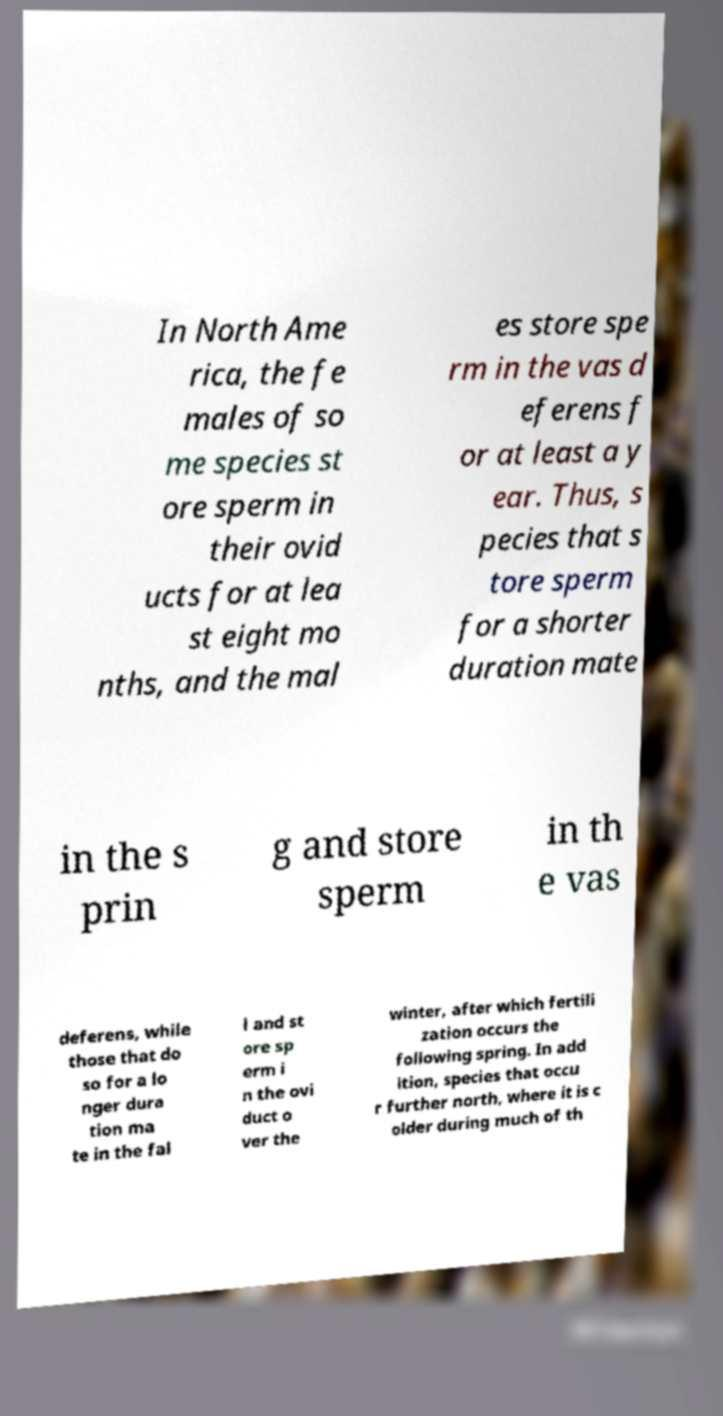Can you accurately transcribe the text from the provided image for me? In North Ame rica, the fe males of so me species st ore sperm in their ovid ucts for at lea st eight mo nths, and the mal es store spe rm in the vas d eferens f or at least a y ear. Thus, s pecies that s tore sperm for a shorter duration mate in the s prin g and store sperm in th e vas deferens, while those that do so for a lo nger dura tion ma te in the fal l and st ore sp erm i n the ovi duct o ver the winter, after which fertili zation occurs the following spring. In add ition, species that occu r further north, where it is c older during much of th 